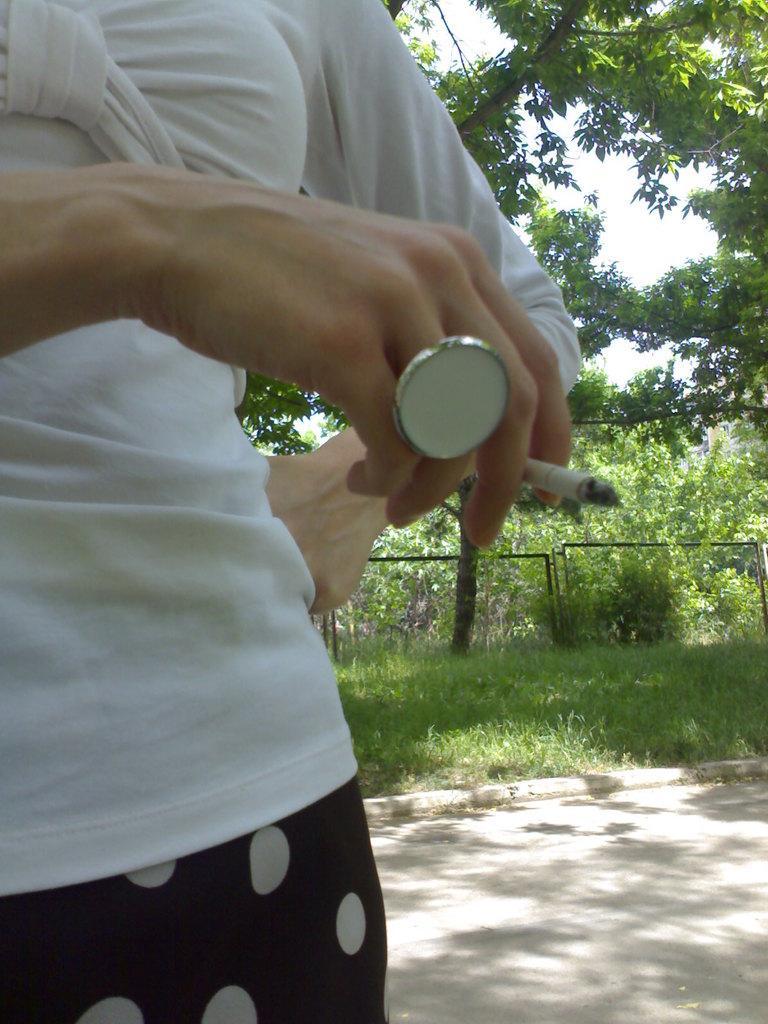Please provide a concise description of this image. In this image there is a person holding cigarette and standing on the path, behind the person there is a grass, roads, trees and the sky. 